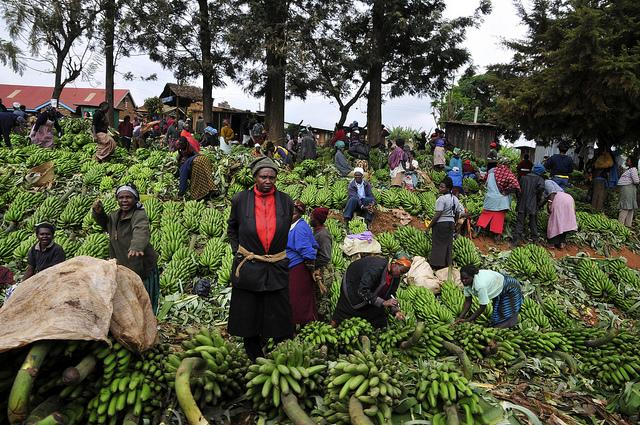What food group do these plantains belong to?

Choices:
A) vegetables
B) grains
C) fruits
D) seeds fruits 